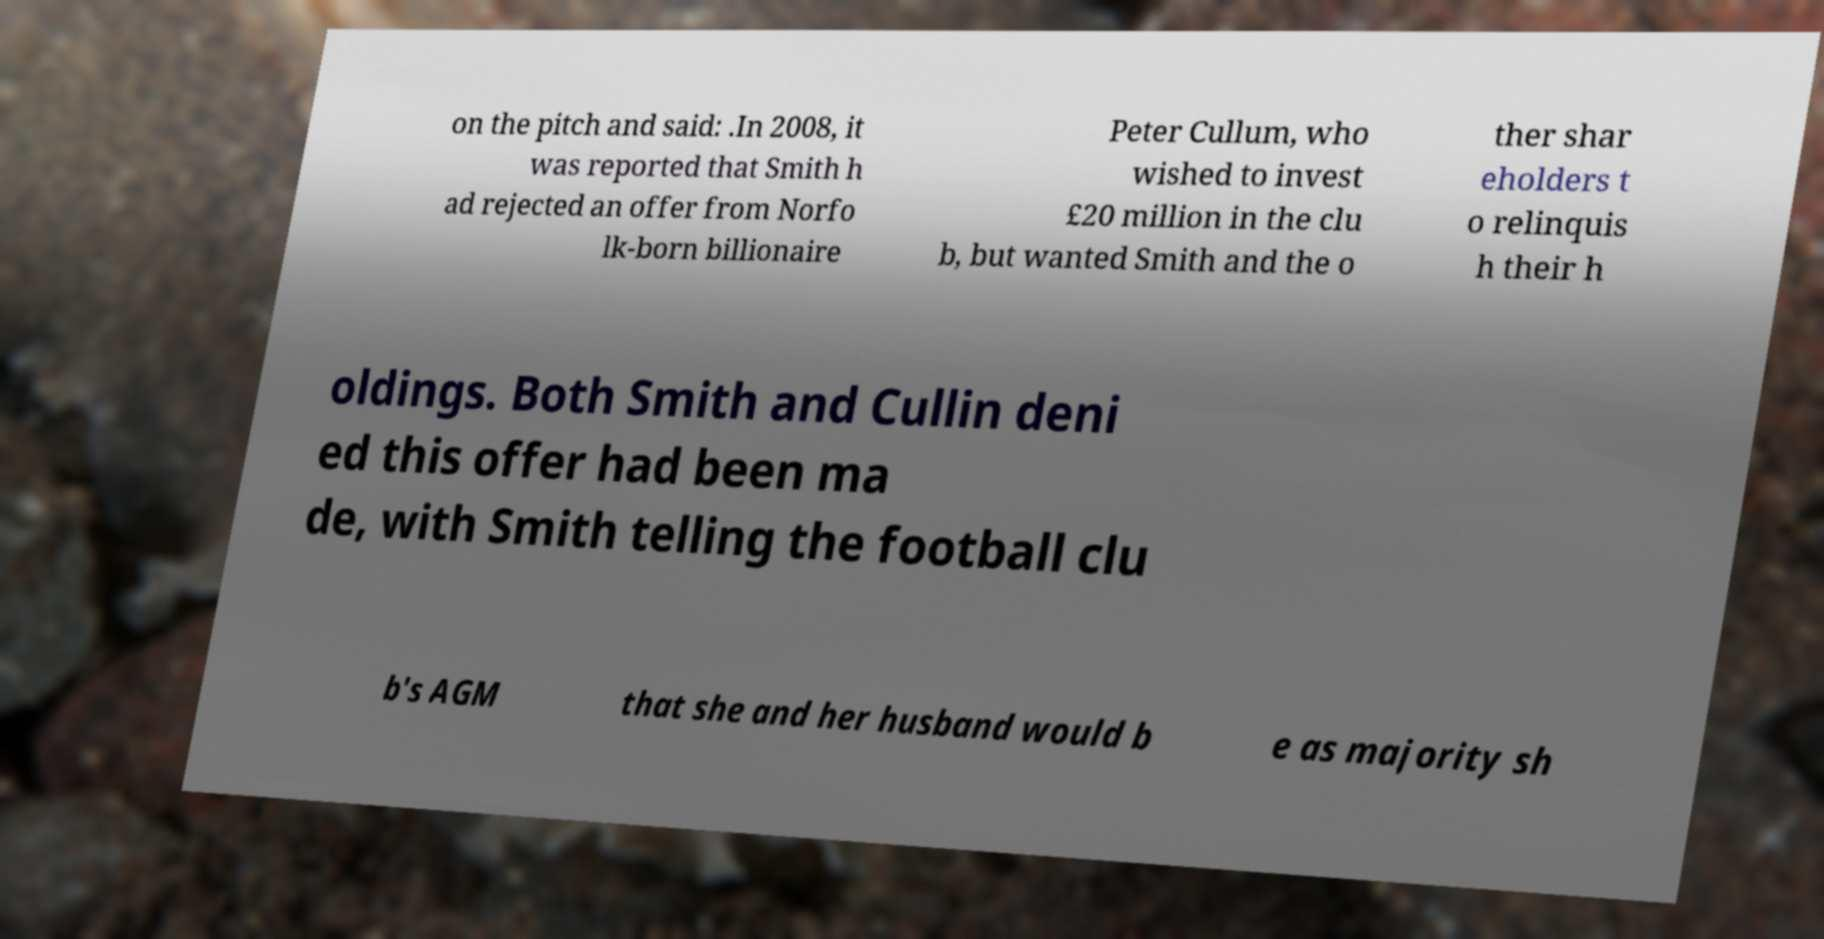Can you accurately transcribe the text from the provided image for me? on the pitch and said: .In 2008, it was reported that Smith h ad rejected an offer from Norfo lk-born billionaire Peter Cullum, who wished to invest £20 million in the clu b, but wanted Smith and the o ther shar eholders t o relinquis h their h oldings. Both Smith and Cullin deni ed this offer had been ma de, with Smith telling the football clu b's AGM that she and her husband would b e as majority sh 